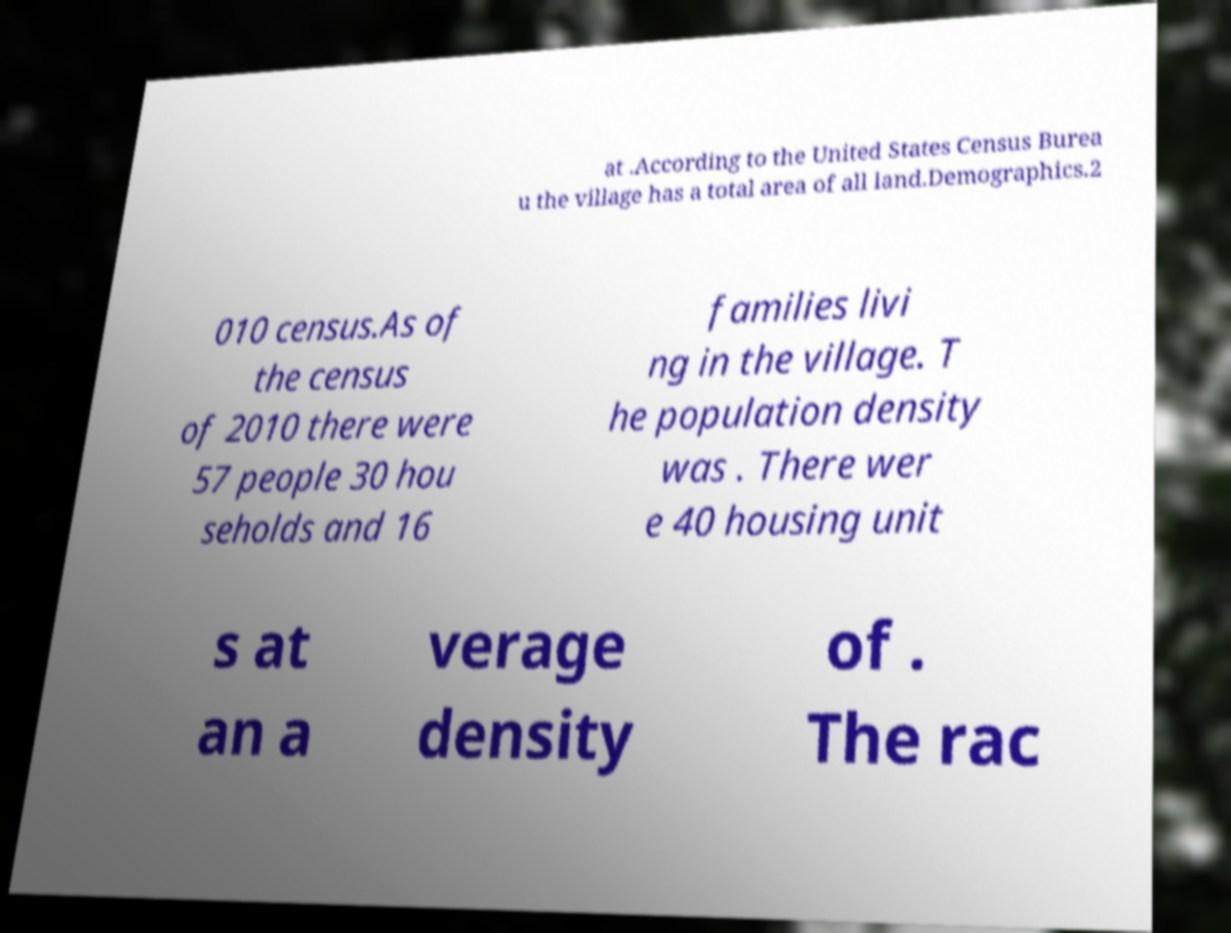Can you accurately transcribe the text from the provided image for me? at .According to the United States Census Burea u the village has a total area of all land.Demographics.2 010 census.As of the census of 2010 there were 57 people 30 hou seholds and 16 families livi ng in the village. T he population density was . There wer e 40 housing unit s at an a verage density of . The rac 